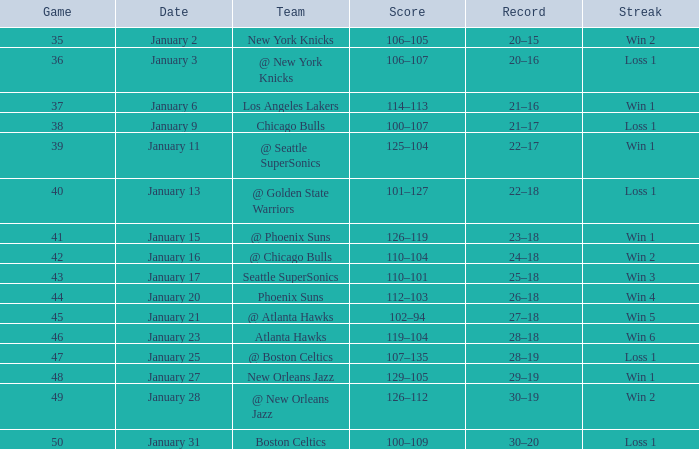In game 41, what is the team involved? @ Phoenix Suns. 